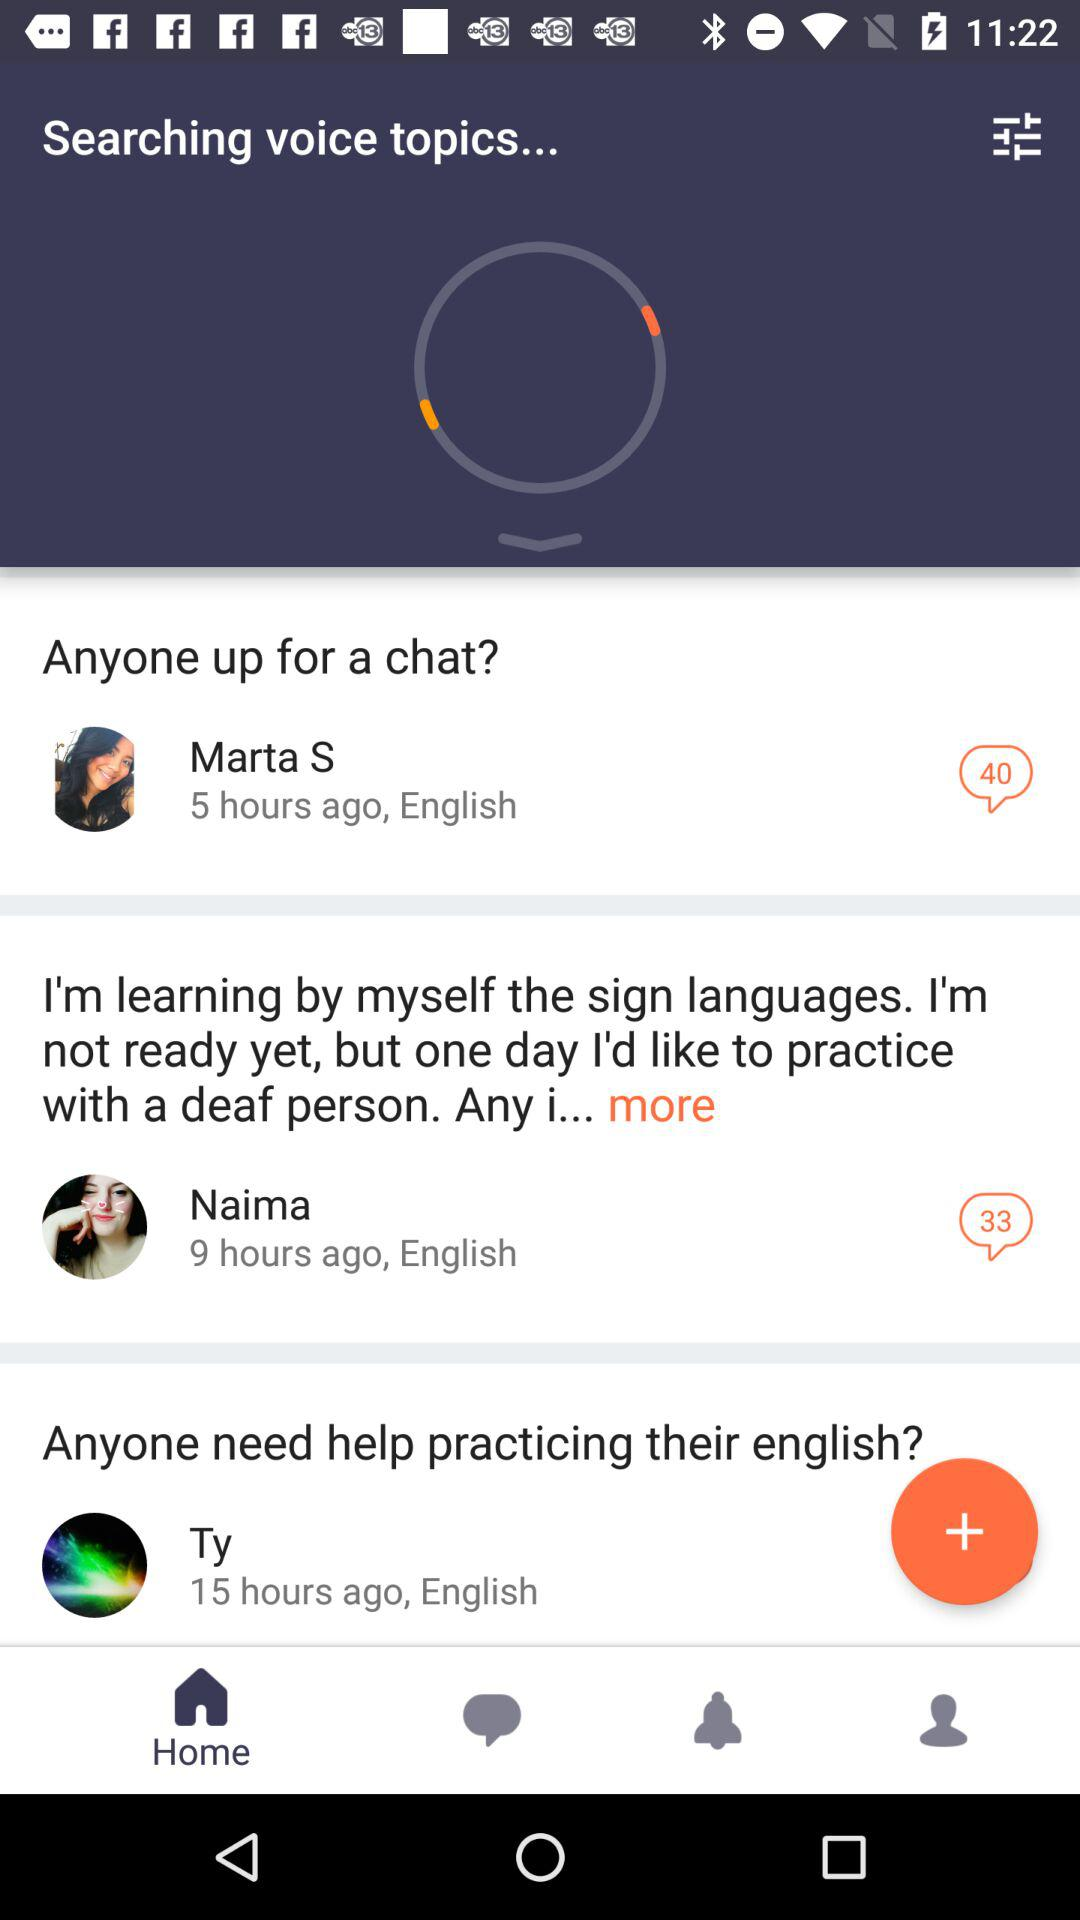How many people are speaking English?
Answer the question using a single word or phrase. 3 